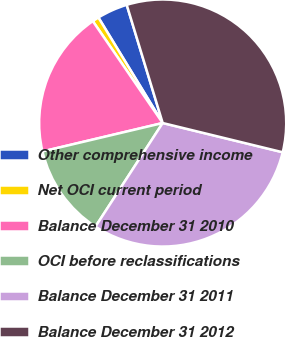<chart> <loc_0><loc_0><loc_500><loc_500><pie_chart><fcel>Other comprehensive income<fcel>Net OCI current period<fcel>Balance December 31 2010<fcel>OCI before reclassifications<fcel>Balance December 31 2011<fcel>Balance December 31 2012<nl><fcel>4.01%<fcel>0.86%<fcel>19.13%<fcel>12.14%<fcel>30.36%<fcel>33.51%<nl></chart> 